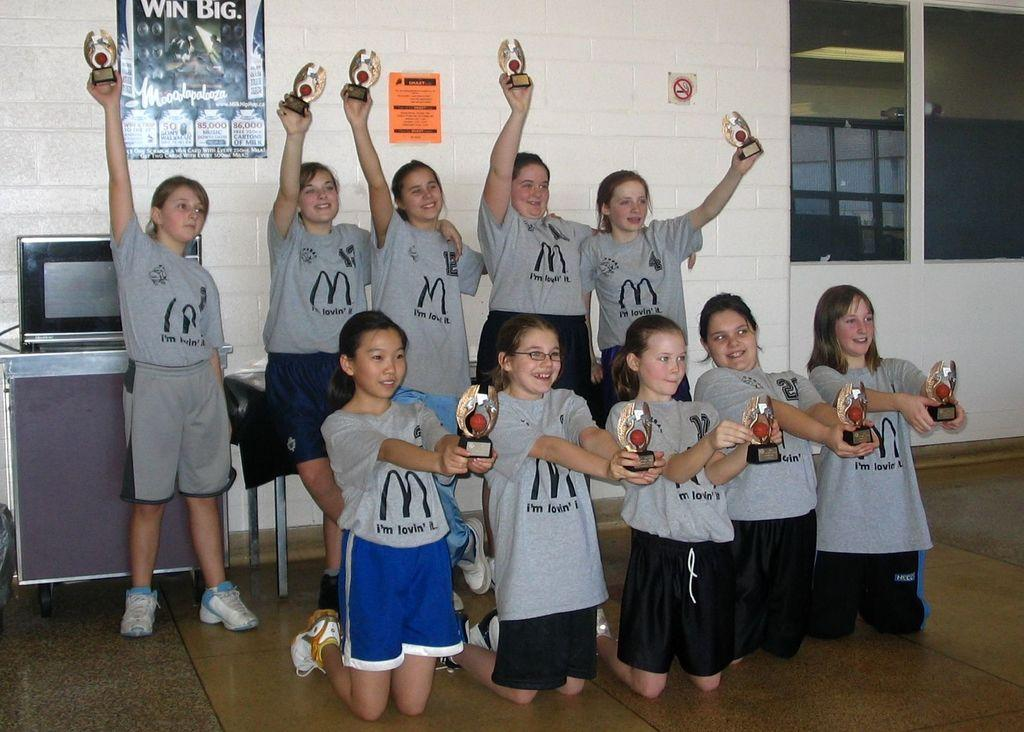<image>
Render a clear and concise summary of the photo. A group of girls holding trophies and wearing Mcdonald's t shirts. 